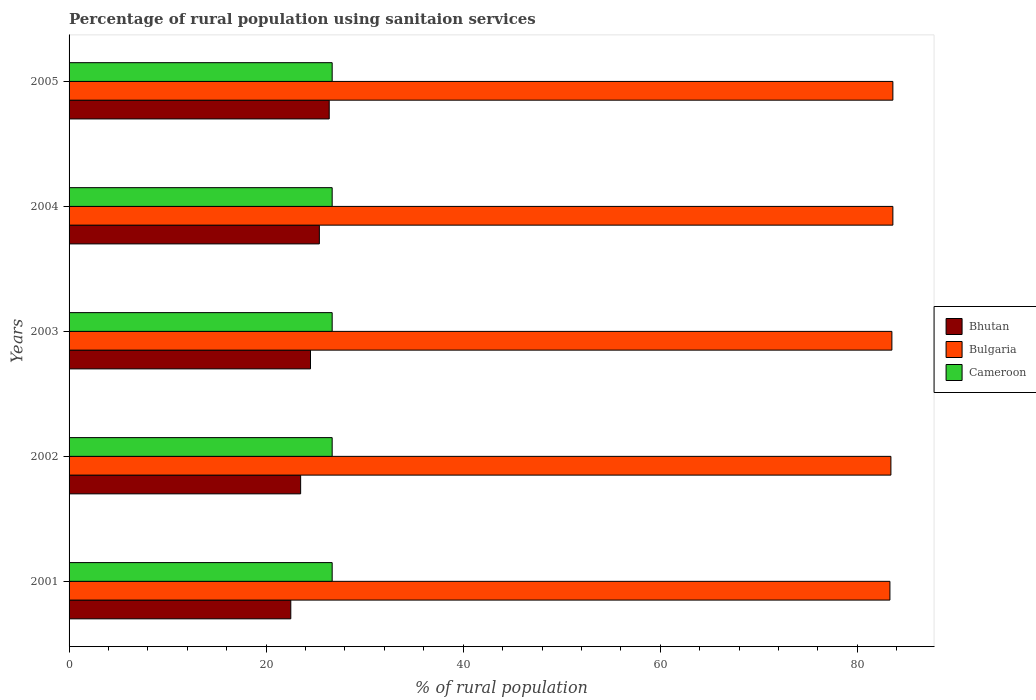How many groups of bars are there?
Your answer should be compact. 5. Are the number of bars per tick equal to the number of legend labels?
Offer a very short reply. Yes. Are the number of bars on each tick of the Y-axis equal?
Provide a succinct answer. Yes. How many bars are there on the 2nd tick from the bottom?
Your response must be concise. 3. What is the label of the 1st group of bars from the top?
Offer a very short reply. 2005. What is the percentage of rural population using sanitaion services in Bulgaria in 2003?
Make the answer very short. 83.5. Across all years, what is the maximum percentage of rural population using sanitaion services in Bulgaria?
Your answer should be compact. 83.6. Across all years, what is the minimum percentage of rural population using sanitaion services in Bhutan?
Keep it short and to the point. 22.5. In which year was the percentage of rural population using sanitaion services in Bulgaria minimum?
Provide a short and direct response. 2001. What is the total percentage of rural population using sanitaion services in Bulgaria in the graph?
Give a very brief answer. 417.4. What is the difference between the percentage of rural population using sanitaion services in Bulgaria in 2002 and that in 2004?
Make the answer very short. -0.2. What is the difference between the percentage of rural population using sanitaion services in Bhutan in 2004 and the percentage of rural population using sanitaion services in Bulgaria in 2005?
Keep it short and to the point. -58.2. What is the average percentage of rural population using sanitaion services in Bhutan per year?
Your answer should be very brief. 24.46. In the year 2001, what is the difference between the percentage of rural population using sanitaion services in Bulgaria and percentage of rural population using sanitaion services in Bhutan?
Offer a very short reply. 60.8. In how many years, is the percentage of rural population using sanitaion services in Bulgaria greater than 56 %?
Provide a short and direct response. 5. What is the ratio of the percentage of rural population using sanitaion services in Cameroon in 2001 to that in 2004?
Your answer should be very brief. 1. Is the percentage of rural population using sanitaion services in Cameroon in 2004 less than that in 2005?
Ensure brevity in your answer.  No. What is the difference between the highest and the second highest percentage of rural population using sanitaion services in Cameroon?
Provide a succinct answer. 0. What is the difference between the highest and the lowest percentage of rural population using sanitaion services in Bulgaria?
Provide a short and direct response. 0.3. In how many years, is the percentage of rural population using sanitaion services in Bhutan greater than the average percentage of rural population using sanitaion services in Bhutan taken over all years?
Keep it short and to the point. 3. Is the sum of the percentage of rural population using sanitaion services in Bhutan in 2002 and 2003 greater than the maximum percentage of rural population using sanitaion services in Bulgaria across all years?
Keep it short and to the point. No. What does the 3rd bar from the top in 2004 represents?
Provide a short and direct response. Bhutan. Are all the bars in the graph horizontal?
Provide a succinct answer. Yes. How many years are there in the graph?
Your answer should be compact. 5. Does the graph contain any zero values?
Offer a very short reply. No. Where does the legend appear in the graph?
Give a very brief answer. Center right. What is the title of the graph?
Your answer should be compact. Percentage of rural population using sanitaion services. What is the label or title of the X-axis?
Make the answer very short. % of rural population. What is the % of rural population of Bulgaria in 2001?
Make the answer very short. 83.3. What is the % of rural population in Cameroon in 2001?
Keep it short and to the point. 26.7. What is the % of rural population in Bhutan in 2002?
Keep it short and to the point. 23.5. What is the % of rural population in Bulgaria in 2002?
Your answer should be compact. 83.4. What is the % of rural population in Cameroon in 2002?
Give a very brief answer. 26.7. What is the % of rural population in Bhutan in 2003?
Keep it short and to the point. 24.5. What is the % of rural population in Bulgaria in 2003?
Make the answer very short. 83.5. What is the % of rural population of Cameroon in 2003?
Provide a succinct answer. 26.7. What is the % of rural population of Bhutan in 2004?
Provide a succinct answer. 25.4. What is the % of rural population of Bulgaria in 2004?
Make the answer very short. 83.6. What is the % of rural population in Cameroon in 2004?
Give a very brief answer. 26.7. What is the % of rural population of Bhutan in 2005?
Give a very brief answer. 26.4. What is the % of rural population in Bulgaria in 2005?
Give a very brief answer. 83.6. What is the % of rural population in Cameroon in 2005?
Make the answer very short. 26.7. Across all years, what is the maximum % of rural population of Bhutan?
Keep it short and to the point. 26.4. Across all years, what is the maximum % of rural population in Bulgaria?
Your answer should be very brief. 83.6. Across all years, what is the maximum % of rural population in Cameroon?
Keep it short and to the point. 26.7. Across all years, what is the minimum % of rural population in Bhutan?
Offer a very short reply. 22.5. Across all years, what is the minimum % of rural population of Bulgaria?
Offer a very short reply. 83.3. Across all years, what is the minimum % of rural population in Cameroon?
Your answer should be compact. 26.7. What is the total % of rural population in Bhutan in the graph?
Your response must be concise. 122.3. What is the total % of rural population of Bulgaria in the graph?
Your answer should be very brief. 417.4. What is the total % of rural population of Cameroon in the graph?
Your response must be concise. 133.5. What is the difference between the % of rural population in Bulgaria in 2001 and that in 2002?
Make the answer very short. -0.1. What is the difference between the % of rural population of Cameroon in 2001 and that in 2003?
Provide a short and direct response. 0. What is the difference between the % of rural population in Bulgaria in 2001 and that in 2004?
Provide a succinct answer. -0.3. What is the difference between the % of rural population of Bulgaria in 2001 and that in 2005?
Keep it short and to the point. -0.3. What is the difference between the % of rural population of Cameroon in 2001 and that in 2005?
Keep it short and to the point. 0. What is the difference between the % of rural population of Bhutan in 2002 and that in 2003?
Your response must be concise. -1. What is the difference between the % of rural population of Cameroon in 2002 and that in 2003?
Provide a succinct answer. 0. What is the difference between the % of rural population of Bulgaria in 2002 and that in 2005?
Give a very brief answer. -0.2. What is the difference between the % of rural population of Cameroon in 2002 and that in 2005?
Your answer should be compact. 0. What is the difference between the % of rural population in Bhutan in 2003 and that in 2004?
Your response must be concise. -0.9. What is the difference between the % of rural population in Bhutan in 2003 and that in 2005?
Keep it short and to the point. -1.9. What is the difference between the % of rural population in Bulgaria in 2004 and that in 2005?
Keep it short and to the point. 0. What is the difference between the % of rural population of Cameroon in 2004 and that in 2005?
Offer a terse response. 0. What is the difference between the % of rural population in Bhutan in 2001 and the % of rural population in Bulgaria in 2002?
Keep it short and to the point. -60.9. What is the difference between the % of rural population in Bhutan in 2001 and the % of rural population in Cameroon in 2002?
Your response must be concise. -4.2. What is the difference between the % of rural population of Bulgaria in 2001 and the % of rural population of Cameroon in 2002?
Offer a terse response. 56.6. What is the difference between the % of rural population in Bhutan in 2001 and the % of rural population in Bulgaria in 2003?
Your answer should be compact. -61. What is the difference between the % of rural population in Bulgaria in 2001 and the % of rural population in Cameroon in 2003?
Provide a succinct answer. 56.6. What is the difference between the % of rural population of Bhutan in 2001 and the % of rural population of Bulgaria in 2004?
Provide a succinct answer. -61.1. What is the difference between the % of rural population in Bulgaria in 2001 and the % of rural population in Cameroon in 2004?
Make the answer very short. 56.6. What is the difference between the % of rural population of Bhutan in 2001 and the % of rural population of Bulgaria in 2005?
Offer a very short reply. -61.1. What is the difference between the % of rural population of Bulgaria in 2001 and the % of rural population of Cameroon in 2005?
Make the answer very short. 56.6. What is the difference between the % of rural population in Bhutan in 2002 and the % of rural population in Bulgaria in 2003?
Make the answer very short. -60. What is the difference between the % of rural population of Bhutan in 2002 and the % of rural population of Cameroon in 2003?
Make the answer very short. -3.2. What is the difference between the % of rural population in Bulgaria in 2002 and the % of rural population in Cameroon in 2003?
Give a very brief answer. 56.7. What is the difference between the % of rural population in Bhutan in 2002 and the % of rural population in Bulgaria in 2004?
Give a very brief answer. -60.1. What is the difference between the % of rural population in Bulgaria in 2002 and the % of rural population in Cameroon in 2004?
Ensure brevity in your answer.  56.7. What is the difference between the % of rural population in Bhutan in 2002 and the % of rural population in Bulgaria in 2005?
Provide a succinct answer. -60.1. What is the difference between the % of rural population in Bulgaria in 2002 and the % of rural population in Cameroon in 2005?
Ensure brevity in your answer.  56.7. What is the difference between the % of rural population of Bhutan in 2003 and the % of rural population of Bulgaria in 2004?
Make the answer very short. -59.1. What is the difference between the % of rural population in Bhutan in 2003 and the % of rural population in Cameroon in 2004?
Ensure brevity in your answer.  -2.2. What is the difference between the % of rural population in Bulgaria in 2003 and the % of rural population in Cameroon in 2004?
Your response must be concise. 56.8. What is the difference between the % of rural population in Bhutan in 2003 and the % of rural population in Bulgaria in 2005?
Offer a very short reply. -59.1. What is the difference between the % of rural population of Bulgaria in 2003 and the % of rural population of Cameroon in 2005?
Offer a terse response. 56.8. What is the difference between the % of rural population in Bhutan in 2004 and the % of rural population in Bulgaria in 2005?
Make the answer very short. -58.2. What is the difference between the % of rural population in Bhutan in 2004 and the % of rural population in Cameroon in 2005?
Your response must be concise. -1.3. What is the difference between the % of rural population in Bulgaria in 2004 and the % of rural population in Cameroon in 2005?
Your answer should be compact. 56.9. What is the average % of rural population of Bhutan per year?
Offer a very short reply. 24.46. What is the average % of rural population in Bulgaria per year?
Give a very brief answer. 83.48. What is the average % of rural population in Cameroon per year?
Offer a terse response. 26.7. In the year 2001, what is the difference between the % of rural population of Bhutan and % of rural population of Bulgaria?
Your answer should be very brief. -60.8. In the year 2001, what is the difference between the % of rural population in Bhutan and % of rural population in Cameroon?
Provide a succinct answer. -4.2. In the year 2001, what is the difference between the % of rural population of Bulgaria and % of rural population of Cameroon?
Give a very brief answer. 56.6. In the year 2002, what is the difference between the % of rural population of Bhutan and % of rural population of Bulgaria?
Ensure brevity in your answer.  -59.9. In the year 2002, what is the difference between the % of rural population of Bulgaria and % of rural population of Cameroon?
Offer a terse response. 56.7. In the year 2003, what is the difference between the % of rural population in Bhutan and % of rural population in Bulgaria?
Your response must be concise. -59. In the year 2003, what is the difference between the % of rural population of Bulgaria and % of rural population of Cameroon?
Your answer should be very brief. 56.8. In the year 2004, what is the difference between the % of rural population in Bhutan and % of rural population in Bulgaria?
Your answer should be very brief. -58.2. In the year 2004, what is the difference between the % of rural population of Bhutan and % of rural population of Cameroon?
Your answer should be very brief. -1.3. In the year 2004, what is the difference between the % of rural population of Bulgaria and % of rural population of Cameroon?
Make the answer very short. 56.9. In the year 2005, what is the difference between the % of rural population in Bhutan and % of rural population in Bulgaria?
Your answer should be compact. -57.2. In the year 2005, what is the difference between the % of rural population of Bhutan and % of rural population of Cameroon?
Keep it short and to the point. -0.3. In the year 2005, what is the difference between the % of rural population in Bulgaria and % of rural population in Cameroon?
Provide a succinct answer. 56.9. What is the ratio of the % of rural population of Bhutan in 2001 to that in 2002?
Provide a short and direct response. 0.96. What is the ratio of the % of rural population of Bulgaria in 2001 to that in 2002?
Offer a terse response. 1. What is the ratio of the % of rural population in Bhutan in 2001 to that in 2003?
Provide a succinct answer. 0.92. What is the ratio of the % of rural population in Bulgaria in 2001 to that in 2003?
Offer a terse response. 1. What is the ratio of the % of rural population of Cameroon in 2001 to that in 2003?
Your answer should be very brief. 1. What is the ratio of the % of rural population in Bhutan in 2001 to that in 2004?
Your answer should be compact. 0.89. What is the ratio of the % of rural population in Cameroon in 2001 to that in 2004?
Give a very brief answer. 1. What is the ratio of the % of rural population in Bhutan in 2001 to that in 2005?
Your answer should be compact. 0.85. What is the ratio of the % of rural population in Bulgaria in 2001 to that in 2005?
Your answer should be very brief. 1. What is the ratio of the % of rural population in Bhutan in 2002 to that in 2003?
Your response must be concise. 0.96. What is the ratio of the % of rural population in Bulgaria in 2002 to that in 2003?
Your answer should be compact. 1. What is the ratio of the % of rural population in Cameroon in 2002 to that in 2003?
Make the answer very short. 1. What is the ratio of the % of rural population of Bhutan in 2002 to that in 2004?
Offer a very short reply. 0.93. What is the ratio of the % of rural population in Bulgaria in 2002 to that in 2004?
Provide a short and direct response. 1. What is the ratio of the % of rural population in Bhutan in 2002 to that in 2005?
Your answer should be compact. 0.89. What is the ratio of the % of rural population of Bulgaria in 2002 to that in 2005?
Offer a very short reply. 1. What is the ratio of the % of rural population in Bhutan in 2003 to that in 2004?
Provide a short and direct response. 0.96. What is the ratio of the % of rural population of Cameroon in 2003 to that in 2004?
Offer a very short reply. 1. What is the ratio of the % of rural population in Bhutan in 2003 to that in 2005?
Make the answer very short. 0.93. What is the ratio of the % of rural population in Cameroon in 2003 to that in 2005?
Provide a succinct answer. 1. What is the ratio of the % of rural population in Bhutan in 2004 to that in 2005?
Your answer should be compact. 0.96. What is the ratio of the % of rural population in Bulgaria in 2004 to that in 2005?
Offer a terse response. 1. What is the ratio of the % of rural population of Cameroon in 2004 to that in 2005?
Offer a terse response. 1. What is the difference between the highest and the second highest % of rural population of Bhutan?
Keep it short and to the point. 1. What is the difference between the highest and the second highest % of rural population in Bulgaria?
Provide a short and direct response. 0. What is the difference between the highest and the second highest % of rural population of Cameroon?
Your answer should be compact. 0. What is the difference between the highest and the lowest % of rural population in Cameroon?
Your response must be concise. 0. 